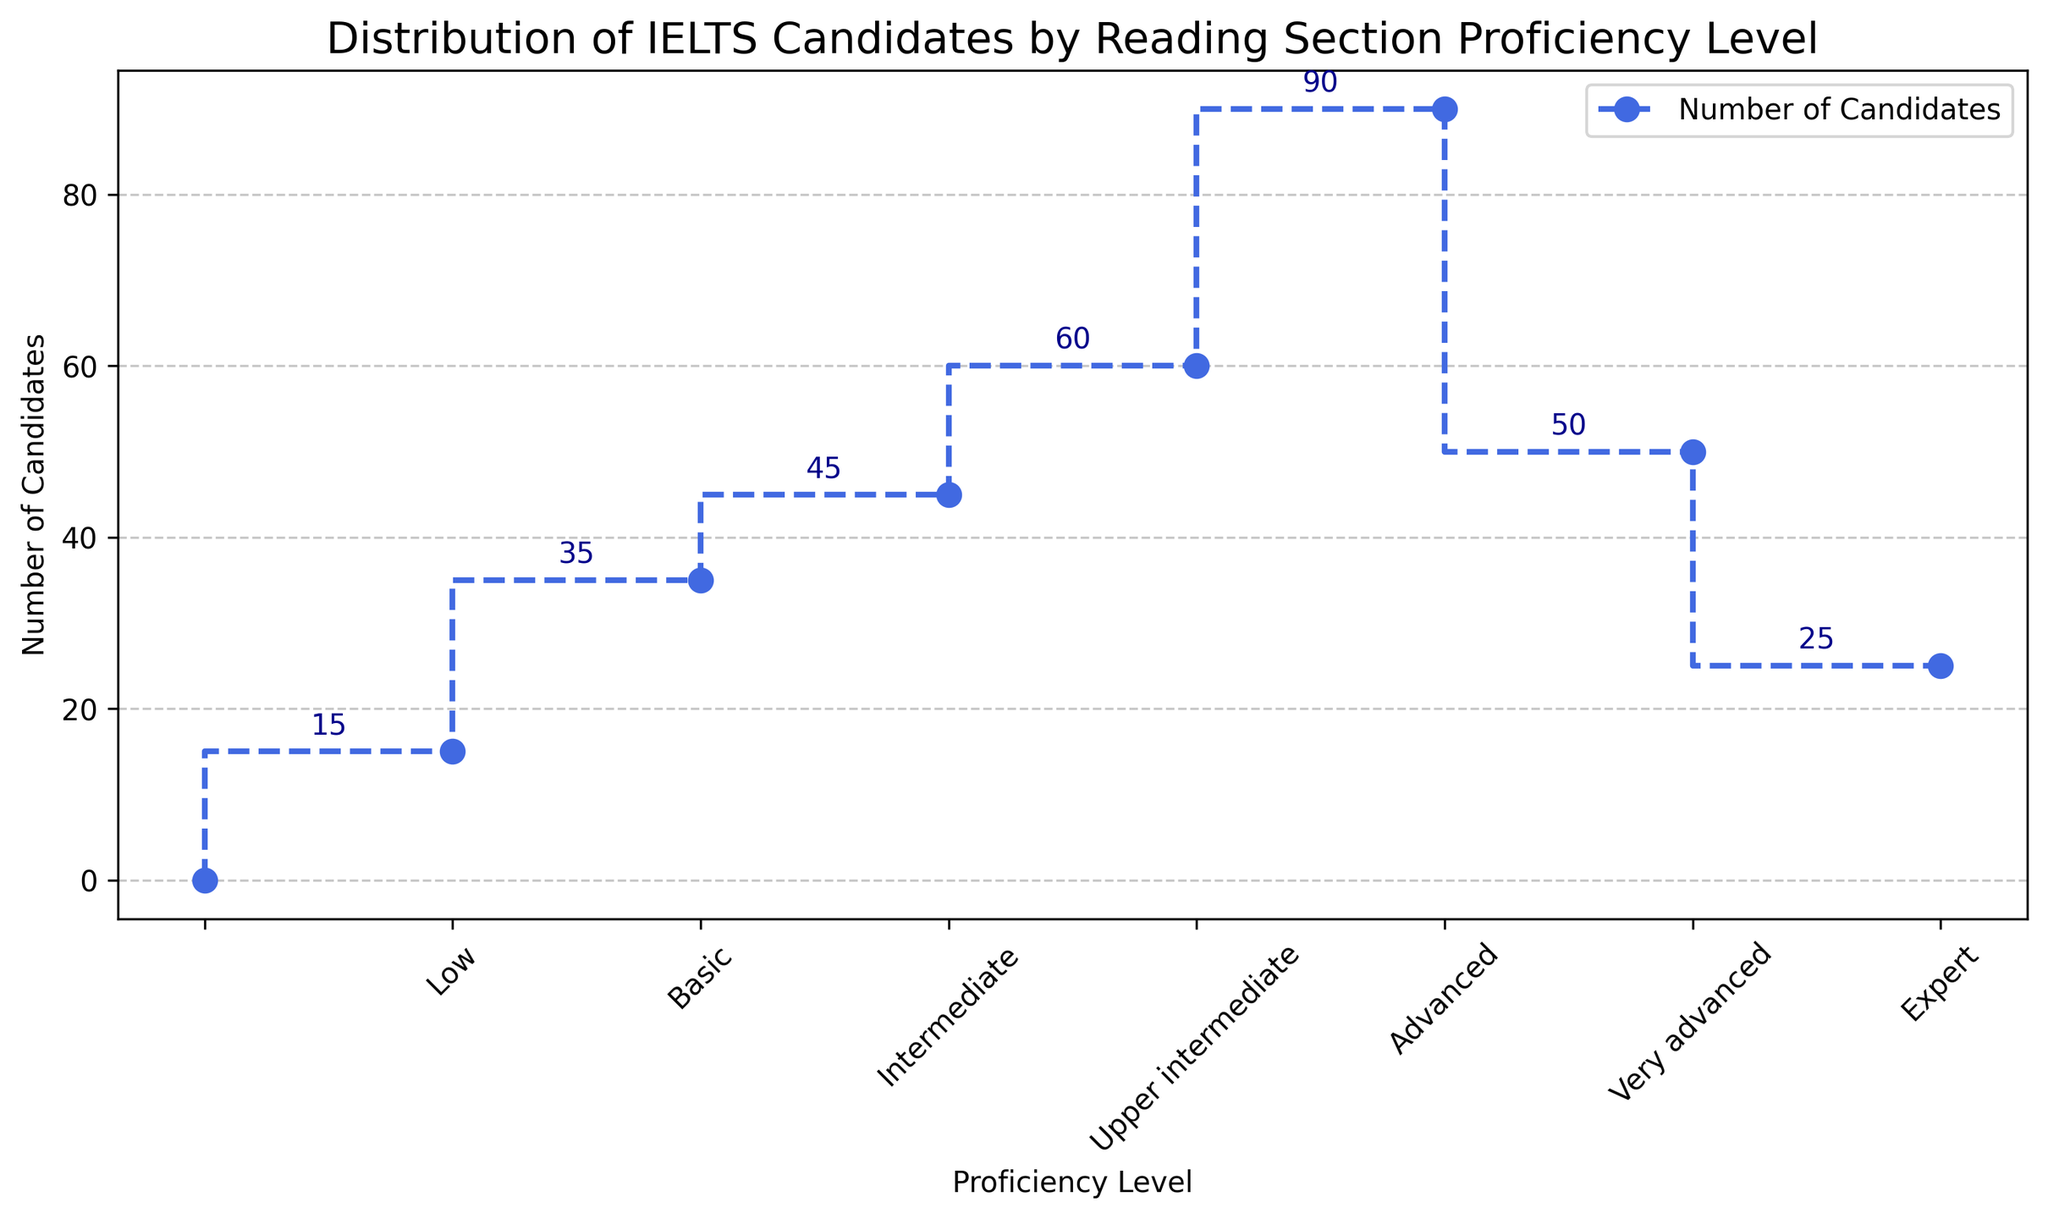What is the total number of candidates for the Basic and Intermediate proficiency levels? According to the figure, the number of candidates for the Basic proficiency level is 35, and for the Intermediate proficiency level, it is 45. Summing these two numbers gives 35 + 45 = 80.
Answer: 80 Which proficiency level has the highest number of candidates? By examining the heights of the markers in the plot, we see that the Advanced level has the highest marker, indicating it has the highest number of candidates, which is 90.
Answer: Advanced What is the difference between the number of candidates at the Basic and Very advanced proficiency levels? The figure shows that the Basic proficiency level has 35 candidates and the Very advanced proficiency level has 50 candidates. The difference is calculated as 50 - 35 = 15.
Answer: 15 Which proficiency level has fewer candidates, Intermediate or Upper intermediate? The plot shows the number of candidates as 45 for Intermediate and 60 for Upper intermediate. Since 45 is less than 60, the Intermediate level has fewer candidates.
Answer: Intermediate How many candidates are at or above the Advanced proficiency level? From the plot, the number of candidates at the Advanced level is 90, Very advanced is 50, and Expert is 25. Summing these gives 90 + 50 + 25 = 165.
Answer: 165 What is the average number of candidates in the Low, Basic, and Intermediate proficiency levels? The figure shows 15 candidates for Low, 35 for Basic, and 45 for Intermediate levels. The sum of these is 15 + 35 + 45 = 95. There are three levels, so the average is 95/3 ≈ 31.67.
Answer: 31.67 Which two adjacent proficiency levels on the stairs plot show the greatest increase in the number of candidates? By examining the steps in the plot, the largest increase is between Upper intermediate (60 candidates) and Advanced (90 candidates), with an increase of 90 - 60 = 30 candidates.
Answer: Upper intermediate to Advanced How many more candidates are there in the Advanced proficiency level compared to both the Low and Basic levels combined? The Advanced proficiency level has 90 candidates. The Low level has 15 candidates and the Basic level has 35 candidates. Combined, Low and Basic levels have 15 + 35 = 50 candidates. The difference is 90 - 50 = 40.
Answer: 40 Between which proficiency levels does the number of candidates increase by exactly 50? Looking at the increases between the steps on the plot, the number of candidates increases from 45 (Intermediate) to 60 (Upper intermediate) which is an increase of 15, and from 60 (Upper intermediate) to 90 (Advanced) which is an increase of 30, none exactly increase by 50. Thus, there is no such increase by exactly 50.
Answer: None 